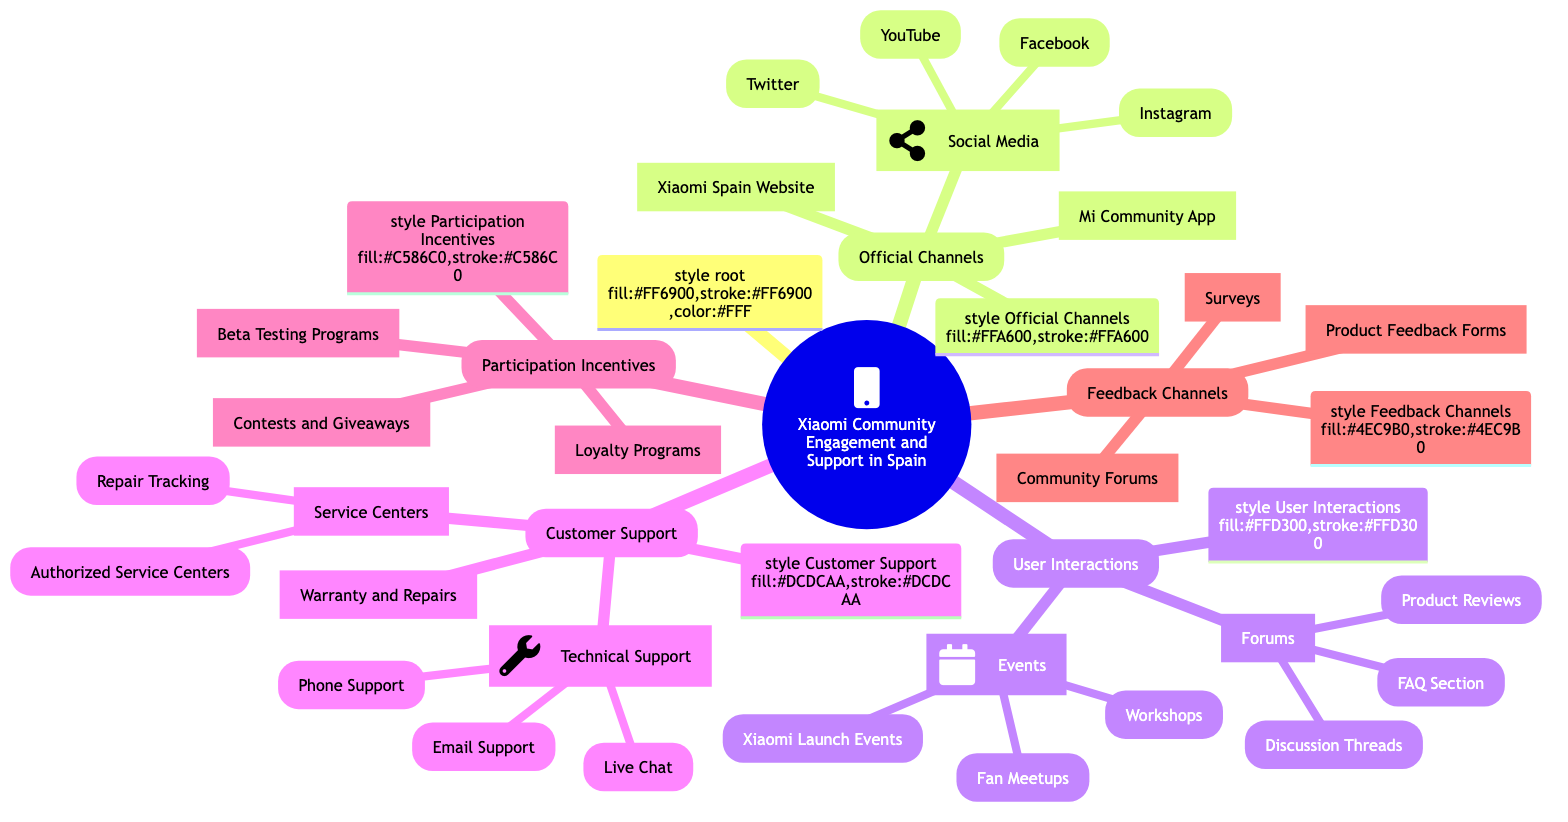What are the main official channels for Xiaomi Community in Spain? The main official channels are represented as the first layer of categories under the root node. They are: Xiaomi Spain Website, Mi Community App, and Social Media.
Answer: Xiaomi Spain Website, Mi Community App, Social Media How many types of user interactions are listed in the diagram? User interactions are grouped under two categories: Forums and Events. So, there are two types of user interactions.
Answer: 2 What communication method is under Technical Support? The Technical Support category lists three methods for communication: Live Chat, Email Support, and Phone Support. These are the branches under Technical Support.
Answer: Live Chat, Email Support, Phone Support What are the incentives for participation mentioned in the diagram? The Participation Incentives category mentions three specific incentives: Contests and Giveaways, Beta Testing Programs, and Loyalty Programs.
Answer: Contests and Giveaways, Beta Testing Programs, Loyalty Programs How many social media platforms are included in the official channels? The Social Media category includes four platforms: Facebook, Instagram, Twitter, and YouTube, which are listed as individual items under Social Media.
Answer: 4 Which section includes a FAQ component? The FAQ component is part of the Forums category, specifically under the User Interactions section. It is listed as an individual node within Forums.
Answer: FAQ Section What summarizes the Customer Support offerings? The Customer Support category consists of three main offerings: Technical Support, Service Centers, and Warranty and Repairs. This is the first level under Customer Support.
Answer: Technical Support, Service Centers, Warranty and Repairs Which channel is iconically represented with a wrench? The wrench icon specifically represents the Technical Support section in the diagram, indicating its focus on support-related services.
Answer: Technical Support 